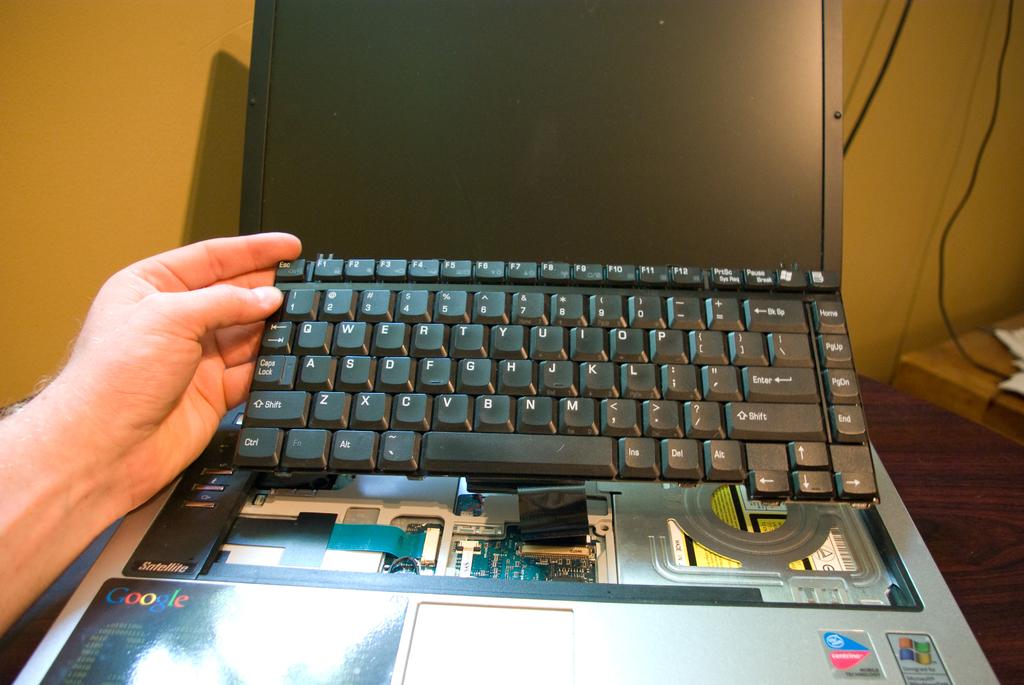What is the name of the word with a multiple of colors?
Offer a very short reply. Google. What operating system does the sticker say it uses?
Provide a short and direct response. Windows. 